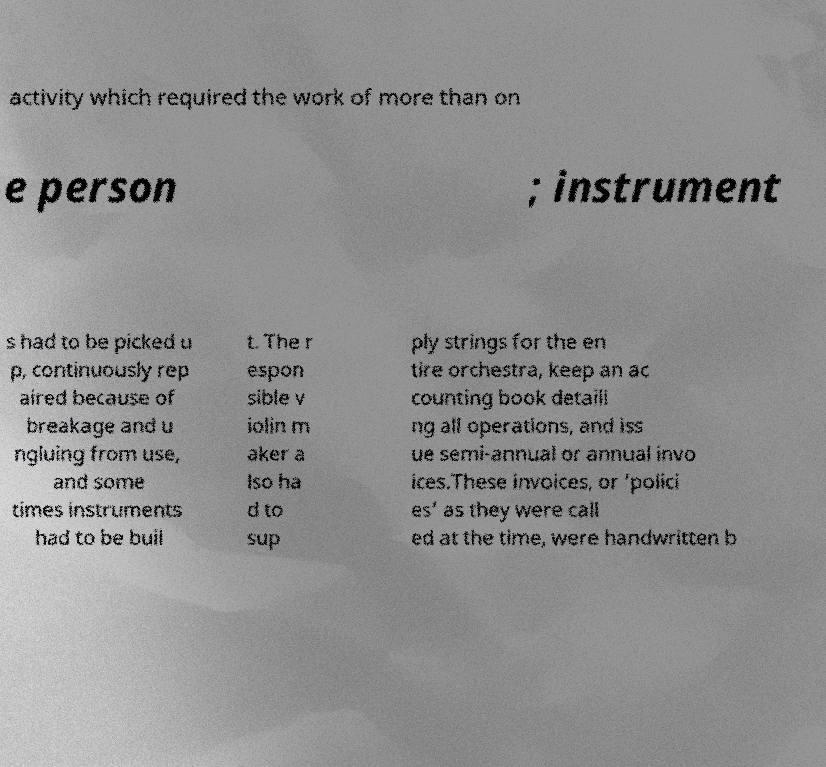I need the written content from this picture converted into text. Can you do that? activity which required the work of more than on e person ; instrument s had to be picked u p, continuously rep aired because of breakage and u ngluing from use, and some times instruments had to be buil t. The r espon sible v iolin m aker a lso ha d to sup ply strings for the en tire orchestra, keep an ac counting book detaili ng all operations, and iss ue semi-annual or annual invo ices.These invoices, or ‘polici es’ as they were call ed at the time, were handwritten b 